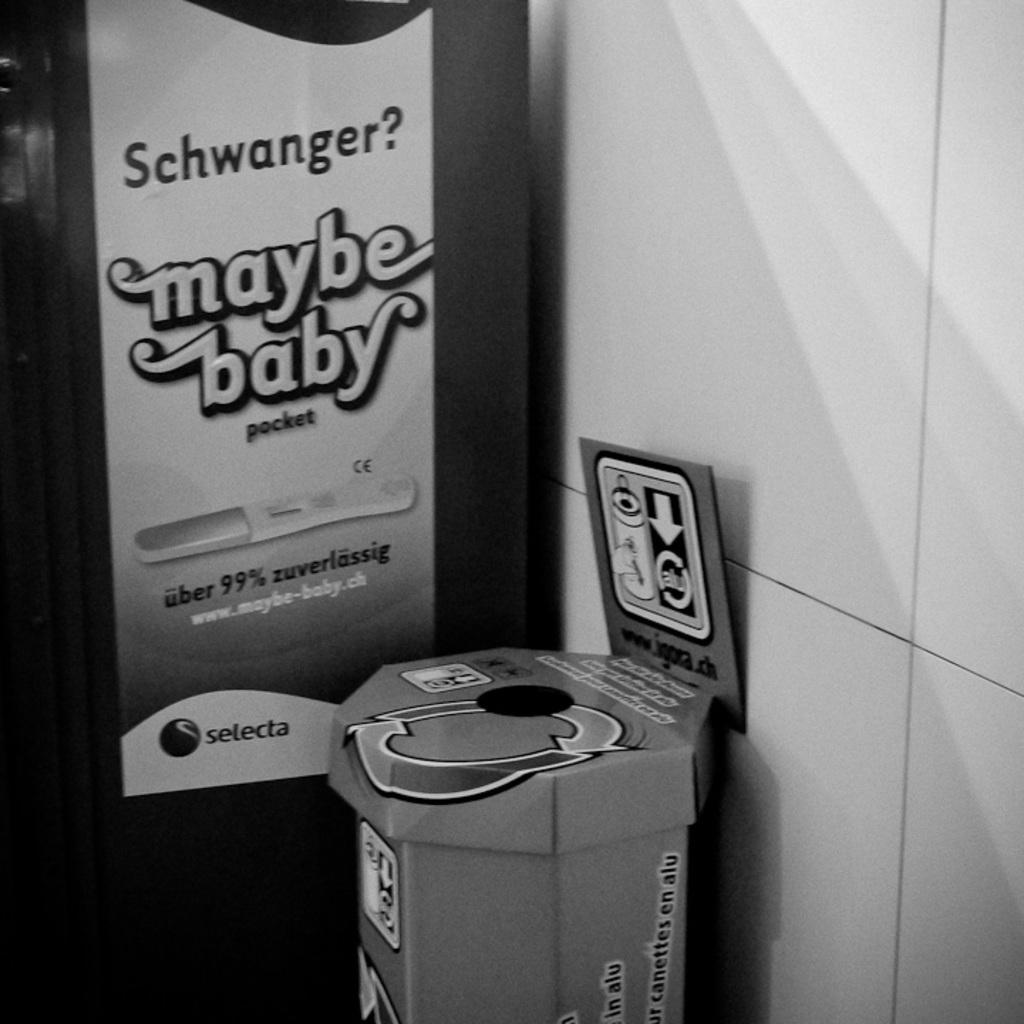<image>
Summarize the visual content of the image. The pregnancy test says it is uber 99% zuverlassig. 